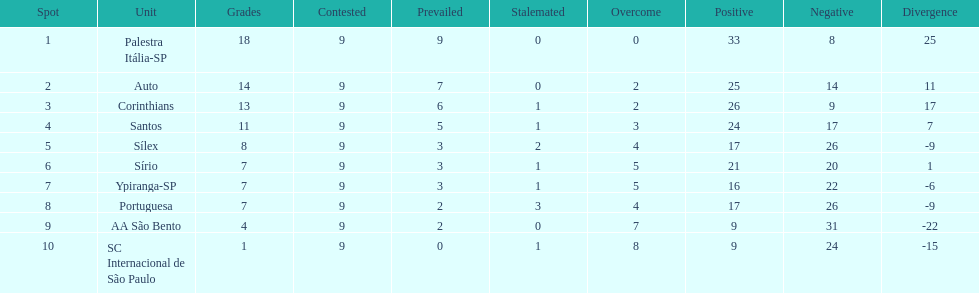Write the full table. {'header': ['Spot', 'Unit', 'Grades', 'Contested', 'Prevailed', 'Stalemated', 'Overcome', 'Positive', 'Negative', 'Divergence'], 'rows': [['1', 'Palestra Itália-SP', '18', '9', '9', '0', '0', '33', '8', '25'], ['2', 'Auto', '14', '9', '7', '0', '2', '25', '14', '11'], ['3', 'Corinthians', '13', '9', '6', '1', '2', '26', '9', '17'], ['4', 'Santos', '11', '9', '5', '1', '3', '24', '17', '7'], ['5', 'Sílex', '8', '9', '3', '2', '4', '17', '26', '-9'], ['6', 'Sírio', '7', '9', '3', '1', '5', '21', '20', '1'], ['7', 'Ypiranga-SP', '7', '9', '3', '1', '5', '16', '22', '-6'], ['8', 'Portuguesa', '7', '9', '2', '3', '4', '17', '26', '-9'], ['9', 'AA São Bento', '4', '9', '2', '0', '7', '9', '31', '-22'], ['10', 'SC Internacional de São Paulo', '1', '9', '0', '1', '8', '9', '24', '-15']]} Which is the only team to score 13 points in 9 games? Corinthians. 